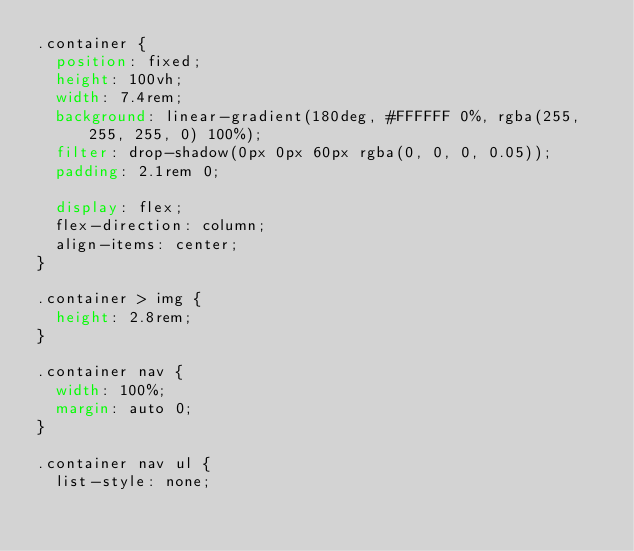<code> <loc_0><loc_0><loc_500><loc_500><_CSS_>.container {
  position: fixed;
  height: 100vh;
  width: 7.4rem;
  background: linear-gradient(180deg, #FFFFFF 0%, rgba(255, 255, 255, 0) 100%);
  filter: drop-shadow(0px 0px 60px rgba(0, 0, 0, 0.05));
  padding: 2.1rem 0;

  display: flex;
  flex-direction: column;
  align-items: center;
}

.container > img {
  height: 2.8rem;
}

.container nav {
  width: 100%;
  margin: auto 0;
}

.container nav ul {
  list-style: none;</code> 